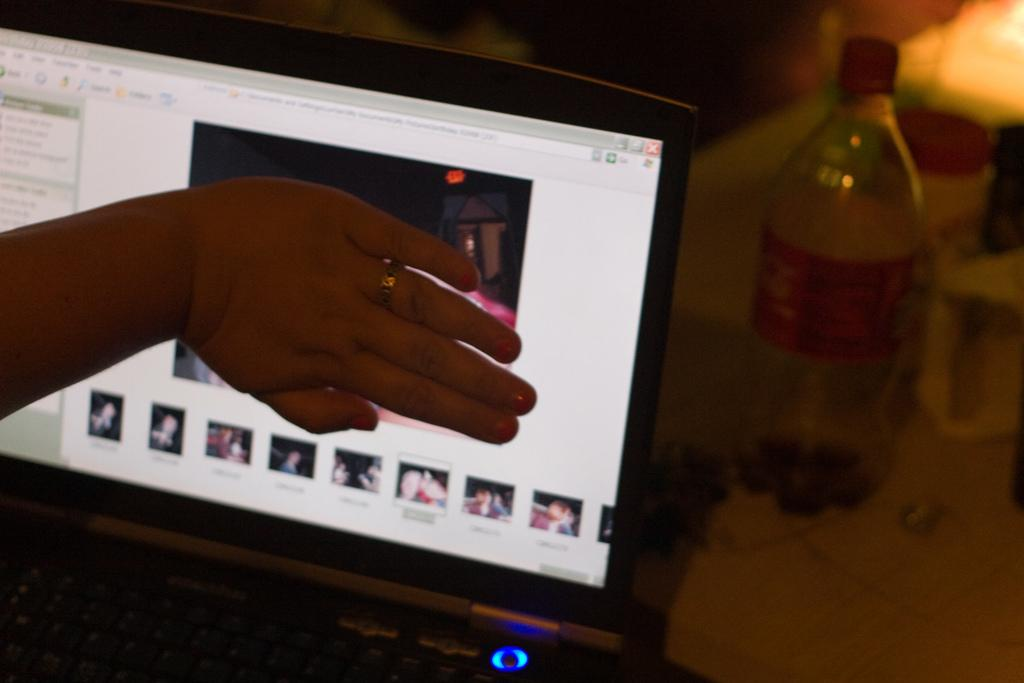What part of a person can be seen in the image? There is a person's hand in the image. What type of surface is visible in the image? There is a desktop in the image. What object is present on the desktop? There is a bottle in the image. What type of slope can be seen in the image? There is no slope present in the image. What boundary is visible in the image? There is no boundary present in the image. 